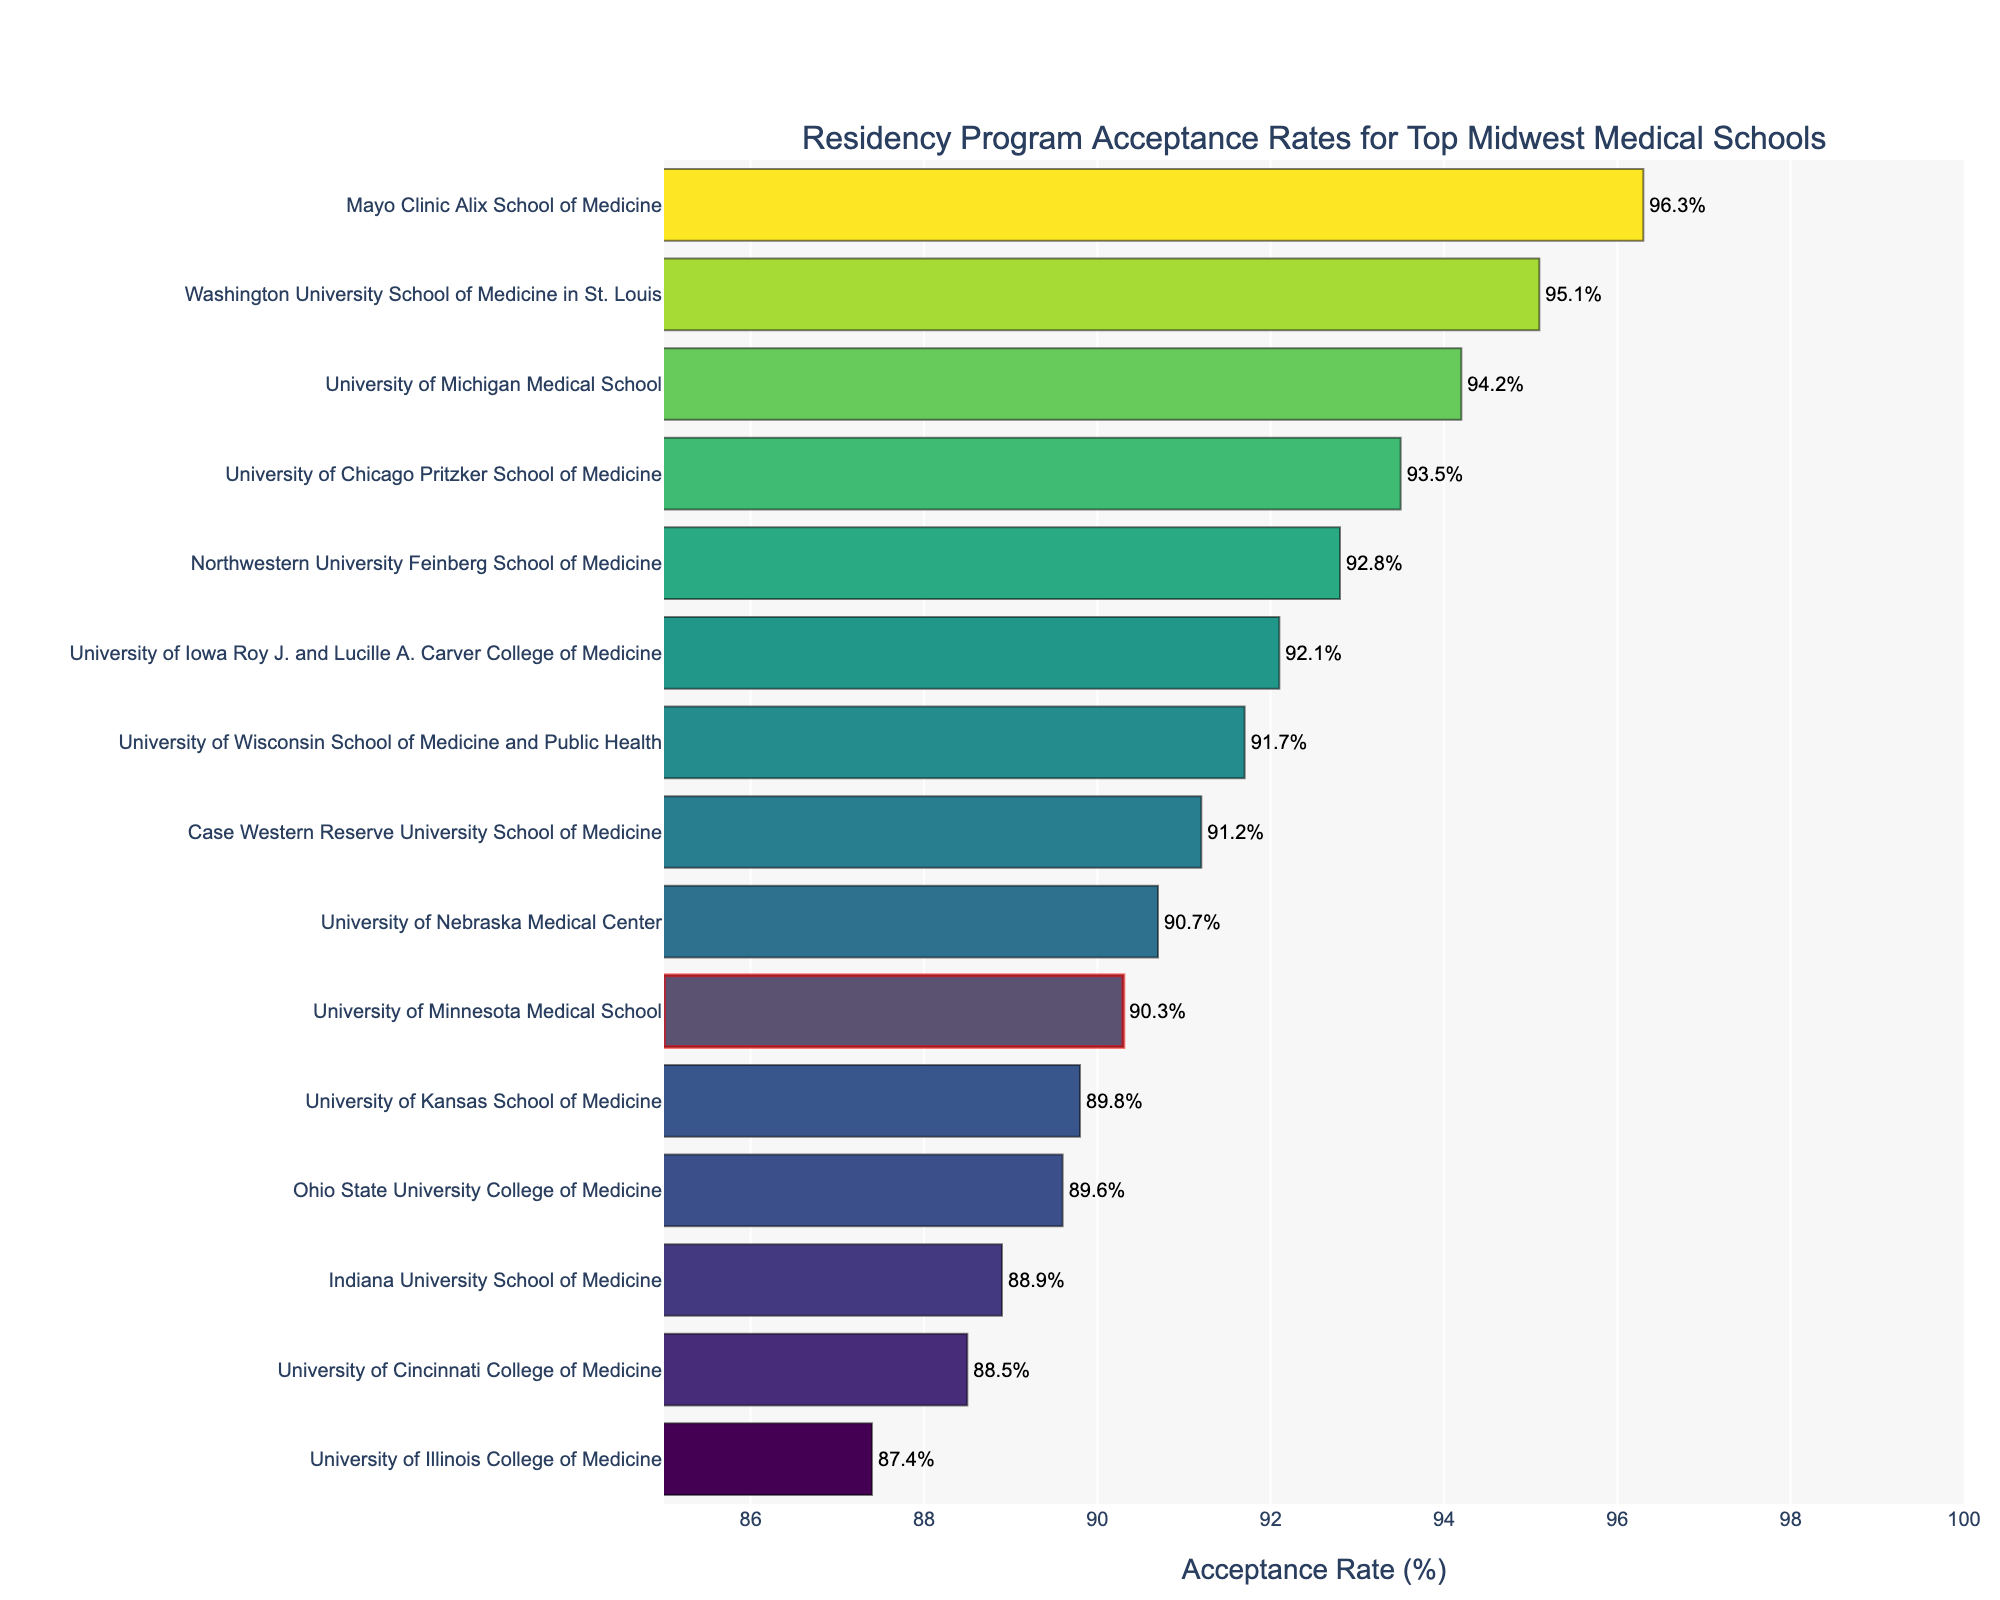What is the acceptance rate of the University of Minnesota Medical School? The bar chart has a specific bar representing the University of Minnesota Medical School, and the label for this bar shows the acceptance rate as a percentage.
Answer: 90.3% Which school has the highest acceptance rate? By examining the bars and their corresponding labels on the bar chart, the school with the highest acceptance rate can be identified by finding the longest bar.
Answer: Mayo Clinic Alix School of Medicine What are the acceptance rates for Indiana University School of Medicine and University of Illinois College of Medicine? Both schools have separate bars on the bar chart, each labeled with their corresponding acceptance rates. By locating these schools, you can read their acceptance rates.
Answer: 88.9% and 87.4%, respectively Arrange the following schools in ascending order of their acceptance rate: University of Michigan Medical School, University of Cincinnati College of Medicine, and University of Kansas School of Medicine. Locate the bars for each of the specified schools, note their acceptance rates, and then arrange them from the smallest to the largest acceptance rate.
Answer: University of Cincinnati College of Medicine (88.5%), University of Kansas School of Medicine (89.8%), University of Michigan Medical School (94.2%) How much higher is the acceptance rate of Washington University School of Medicine in St. Louis compared to Ohio State University College of Medicine? Find the acceptance rates of the two schools on the bar chart and calculate the difference by subtracting the acceptance rate of Ohio State University College of Medicine from that of Washington University School of Medicine in St. Louis.
Answer: 5.5% What is the average acceptance rate of all the schools listed? Observe the acceptance rates of all the bars, sum them up, and then divide by the total number of schools to find the average acceptance rate.
Answer: (94.2 + 92.8 + 93.5 + 95.1 + 91.7 + 90.3 + 89.6 + 92.1 + 88.9 + 87.4 + 96.3 + 91.2 + 88.5 + 89.8 + 90.7) / 15 = 91.6% Which schools have acceptance rates greater than 90%? Identify the bars with acceptance rates above 90% by examining the labels of the respective bars on the bar chart.
Answer: University of Michigan Medical School, Northwestern University Feinberg School of Medicine, University of Chicago Pritzker School of Medicine, Washington University School of Medicine in St. Louis, University of Wisconsin School of Medicine and Public Health, University of Minnesota Medical School, University of Iowa Roy J. and Lucille A. Carver College of Medicine, Mayo Clinic Alix School of Medicine, Case Western Reserve University School of Medicine, University of Nebraska Medical Center 